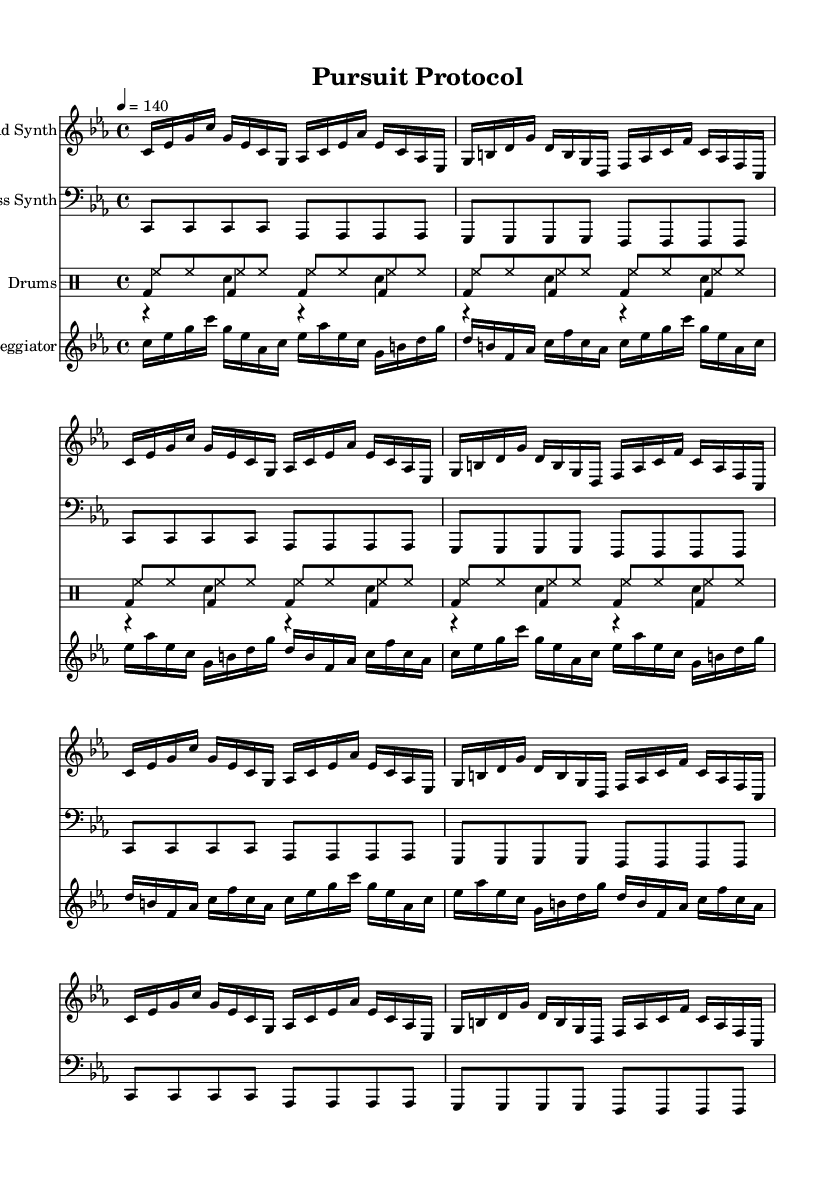What is the key signature of this music? The key signature shown in the music is C minor, as indicated by the presence of three flats (B♭, E♭, A♭).
Answer: C minor What is the time signature of this music? The time signature displayed in the music is 4/4, which means there are four beats in each measure and the quarter note receives one beat.
Answer: 4/4 What is the tempo marking for this piece? The tempo marking is 4 beats per minute set at 140, indicating a brisk pace suitable for an intense electronic track.
Answer: 140 How many measures are repeated in the piece? The repeating section consists of 4 measures, as indicated by the instruction to "repeat unfold 4".
Answer: 4 Which instrument holds the main melodic line? The Lead Synth instrument plays the primary melodic line throughout the piece, showcasing an engaging melody suited for a chase scene.
Answer: Lead Synth What rhythmic pattern is used in the bass synth? The bass synth features a steady quarter note pattern played consistently throughout the piece, contributing to the driving rhythm.
Answer: Quarter notes What unique structure is present in the arpeggiator part? The arpeggiator part uses rapid sixteenth notes, creating a flowing and intricate texture that enhances the intensity and urgency of the music.
Answer: Sixteenth notes 